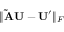<formula> <loc_0><loc_0><loc_500><loc_500>\| \tilde { A } U - U ^ { \prime } \| _ { F }</formula> 